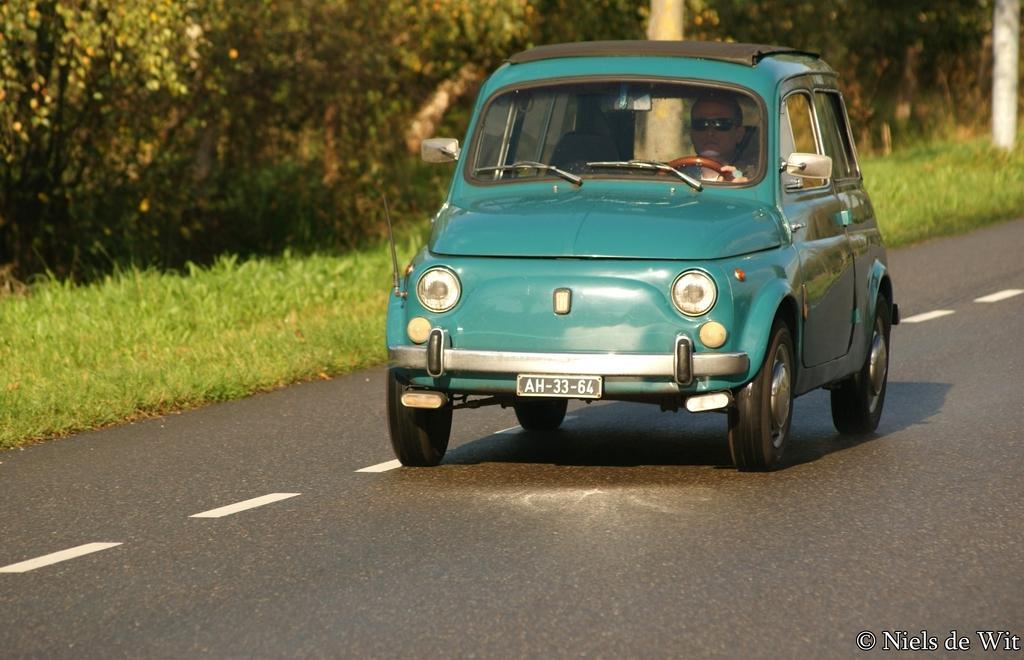Can you describe this image briefly? In this image in front there is a cars on the road. There is a person sitting inside the car. On the left side of the image there is grass on the surface. In the background of the image there are trees, poles. There is some text on the right side of the image. 